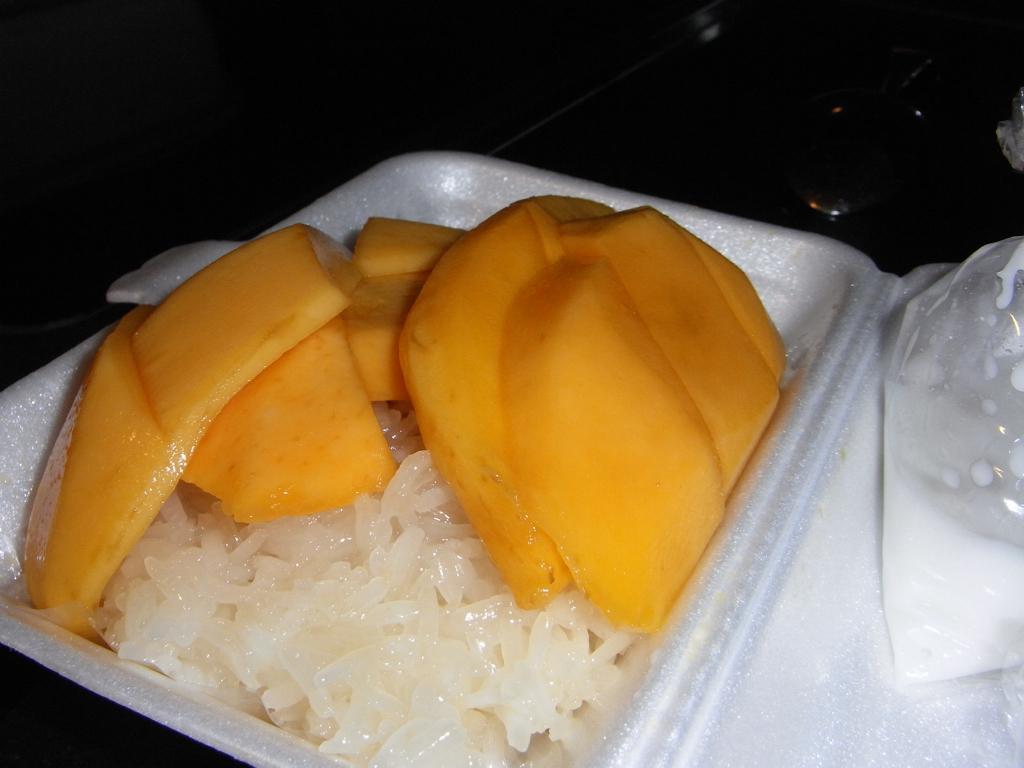Please provide a concise description of this image. In this image we can see mango slices, rice and cover with food item are kept on the white color thermocol plate. The background of the image is dark. 